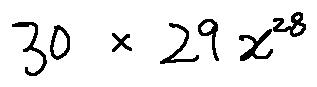<formula> <loc_0><loc_0><loc_500><loc_500>3 0 \times 2 9 x ^ { 2 8 }</formula> 